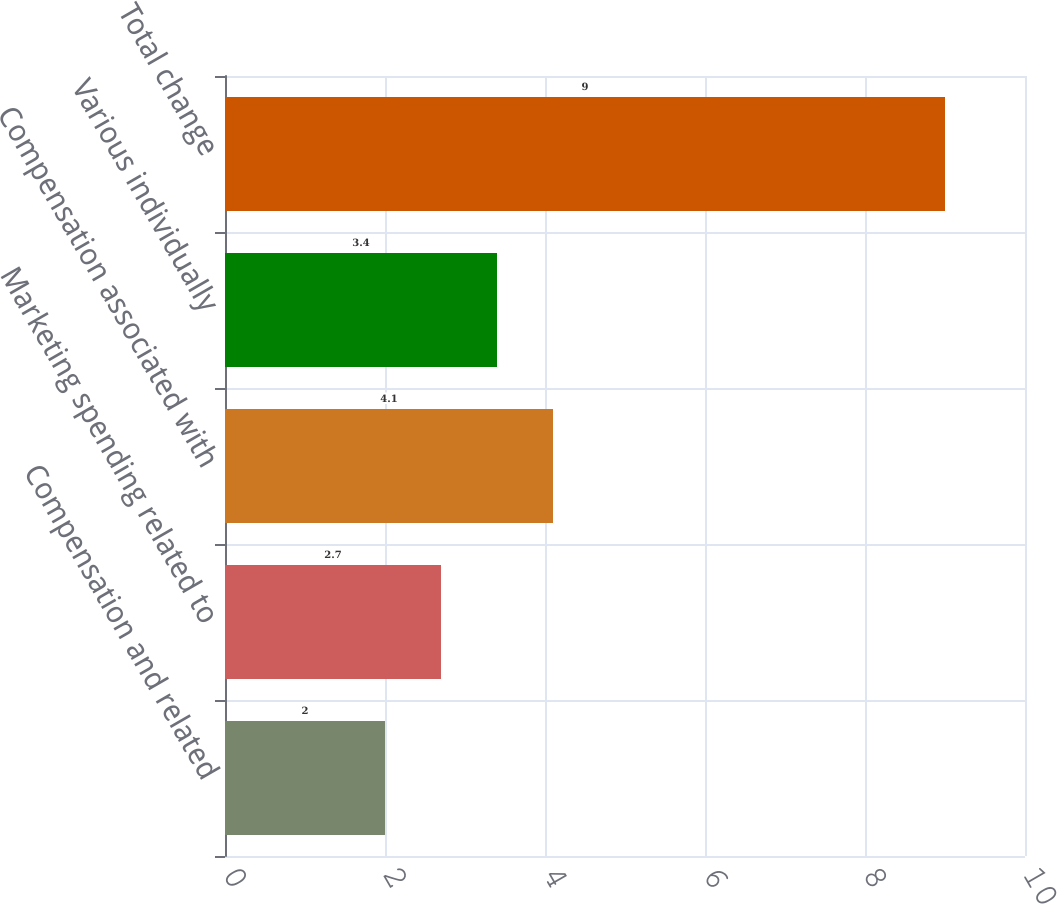Convert chart to OTSL. <chart><loc_0><loc_0><loc_500><loc_500><bar_chart><fcel>Compensation and related<fcel>Marketing spending related to<fcel>Compensation associated with<fcel>Various individually<fcel>Total change<nl><fcel>2<fcel>2.7<fcel>4.1<fcel>3.4<fcel>9<nl></chart> 